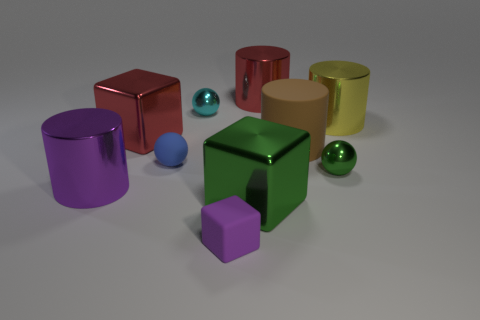What number of other objects are there of the same shape as the big brown object?
Offer a very short reply. 3. The object that is to the left of the small blue matte thing and in front of the large matte thing is what color?
Offer a terse response. Purple. The matte cylinder has what color?
Your answer should be compact. Brown. Does the big brown cylinder have the same material as the cube that is behind the purple metal cylinder?
Keep it short and to the point. No. There is a tiny blue object that is the same material as the brown cylinder; what shape is it?
Offer a terse response. Sphere. There is a block that is the same size as the matte ball; what is its color?
Your answer should be compact. Purple. There is a green metallic thing left of the brown cylinder; is its size the same as the big purple shiny object?
Offer a very short reply. Yes. How many big red objects are there?
Make the answer very short. 2. What number of cylinders are tiny purple things or big yellow things?
Give a very brief answer. 1. What number of shiny cubes are left of the small rubber thing in front of the blue matte object?
Provide a short and direct response. 1. 